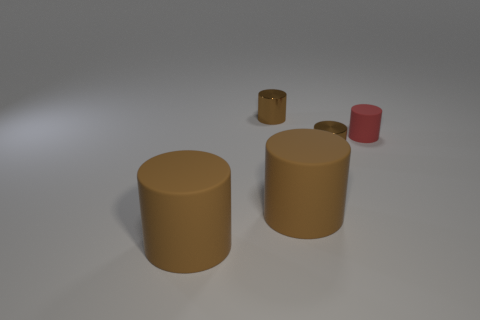How many objects are brown metallic objects that are behind the red cylinder or big matte cylinders to the left of the red rubber object?
Your answer should be very brief. 3. Do the metal cylinder in front of the red matte object and the red matte cylinder have the same size?
Ensure brevity in your answer.  Yes. How many other objects are there of the same size as the red object?
Your answer should be compact. 2. What number of objects have the same color as the small rubber cylinder?
Your response must be concise. 0. The red object has what shape?
Keep it short and to the point. Cylinder. What material is the red object?
Ensure brevity in your answer.  Rubber. The brown object behind the red object has what shape?
Give a very brief answer. Cylinder. Do the tiny cylinder in front of the tiny rubber object and the red thing have the same material?
Offer a very short reply. No. How big is the shiny thing that is in front of the small red object?
Offer a very short reply. Small. The object that is on the right side of the shiny object to the right of the brown cylinder that is behind the small rubber cylinder is what shape?
Make the answer very short. Cylinder. 